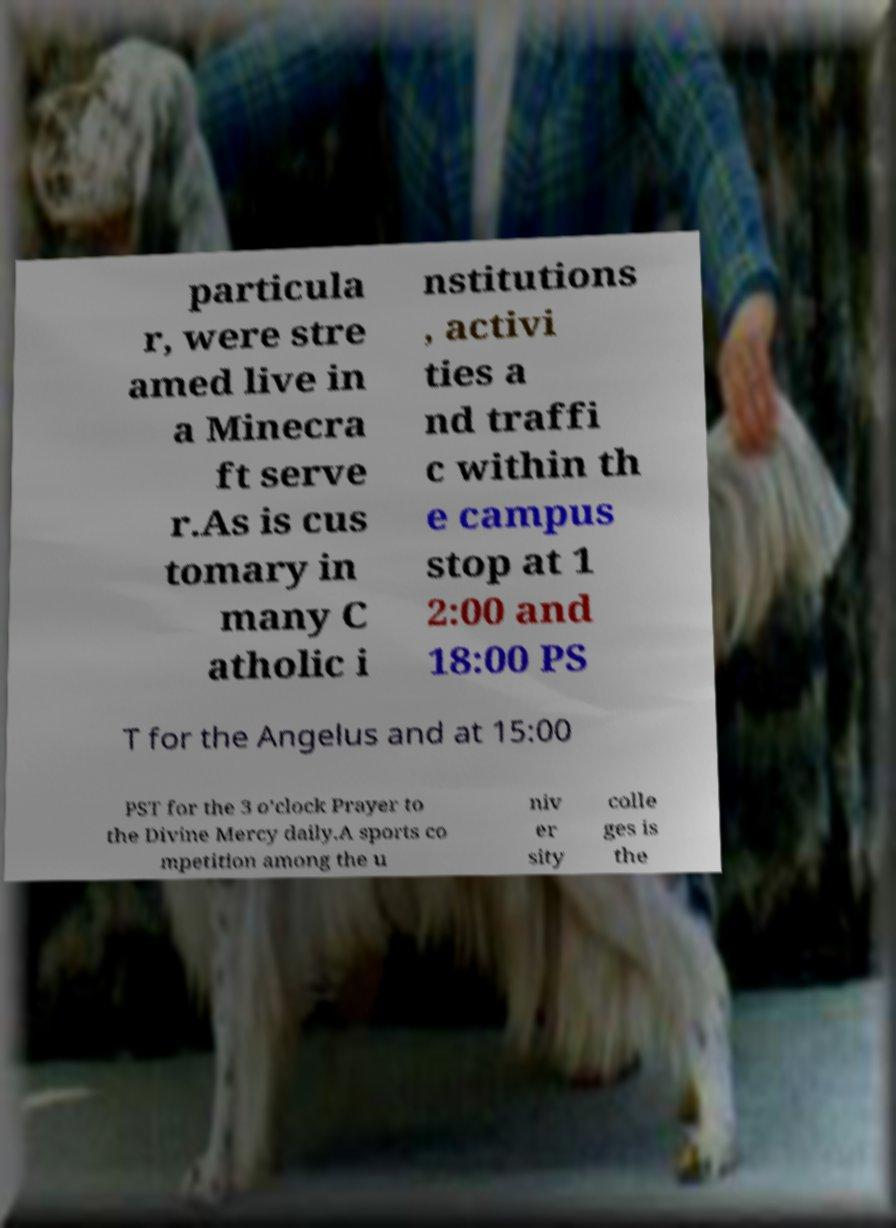For documentation purposes, I need the text within this image transcribed. Could you provide that? particula r, were stre amed live in a Minecra ft serve r.As is cus tomary in many C atholic i nstitutions , activi ties a nd traffi c within th e campus stop at 1 2:00 and 18:00 PS T for the Angelus and at 15:00 PST for the 3 o’clock Prayer to the Divine Mercy daily.A sports co mpetition among the u niv er sity colle ges is the 